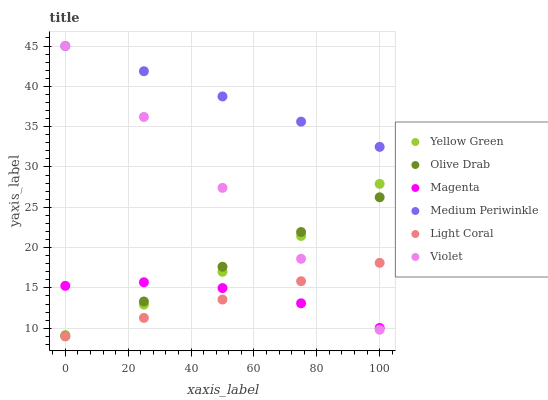Does Light Coral have the minimum area under the curve?
Answer yes or no. Yes. Does Medium Periwinkle have the maximum area under the curve?
Answer yes or no. Yes. Does Medium Periwinkle have the minimum area under the curve?
Answer yes or no. No. Does Light Coral have the maximum area under the curve?
Answer yes or no. No. Is Medium Periwinkle the smoothest?
Answer yes or no. Yes. Is Magenta the roughest?
Answer yes or no. Yes. Is Light Coral the smoothest?
Answer yes or no. No. Is Light Coral the roughest?
Answer yes or no. No. Does Light Coral have the lowest value?
Answer yes or no. Yes. Does Medium Periwinkle have the lowest value?
Answer yes or no. No. Does Violet have the highest value?
Answer yes or no. Yes. Does Light Coral have the highest value?
Answer yes or no. No. Is Light Coral less than Medium Periwinkle?
Answer yes or no. Yes. Is Medium Periwinkle greater than Olive Drab?
Answer yes or no. Yes. Does Light Coral intersect Violet?
Answer yes or no. Yes. Is Light Coral less than Violet?
Answer yes or no. No. Is Light Coral greater than Violet?
Answer yes or no. No. Does Light Coral intersect Medium Periwinkle?
Answer yes or no. No. 